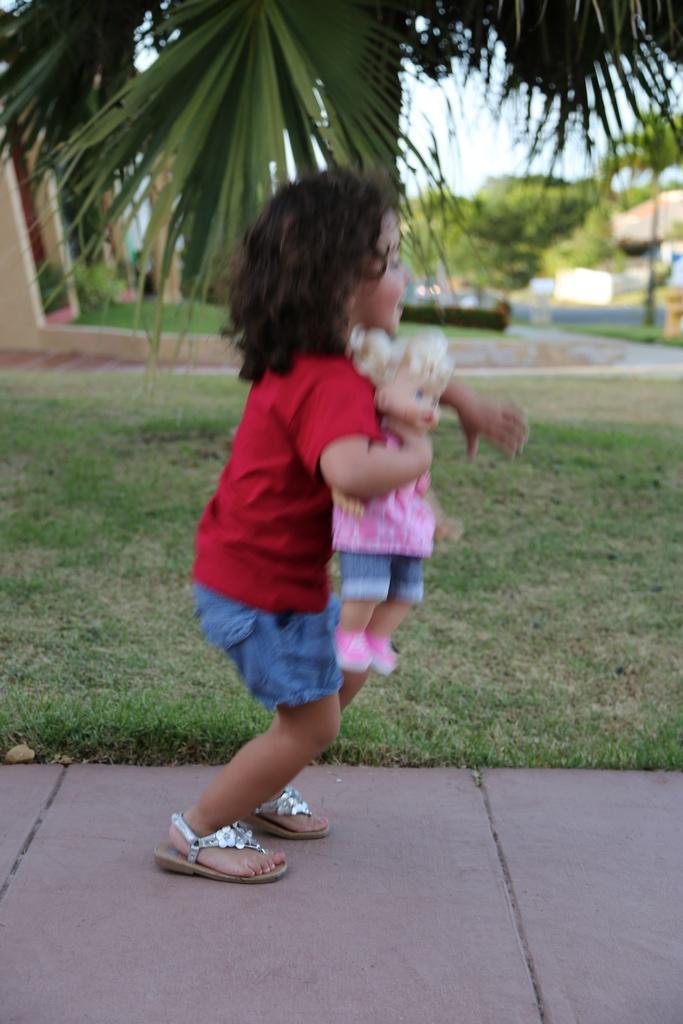Describe this image in one or two sentences. In this picture there is a small girl in the center of the image, by holding a doll in her hand and there is grassland behind her, there is a house and trees in the background area of the image. 